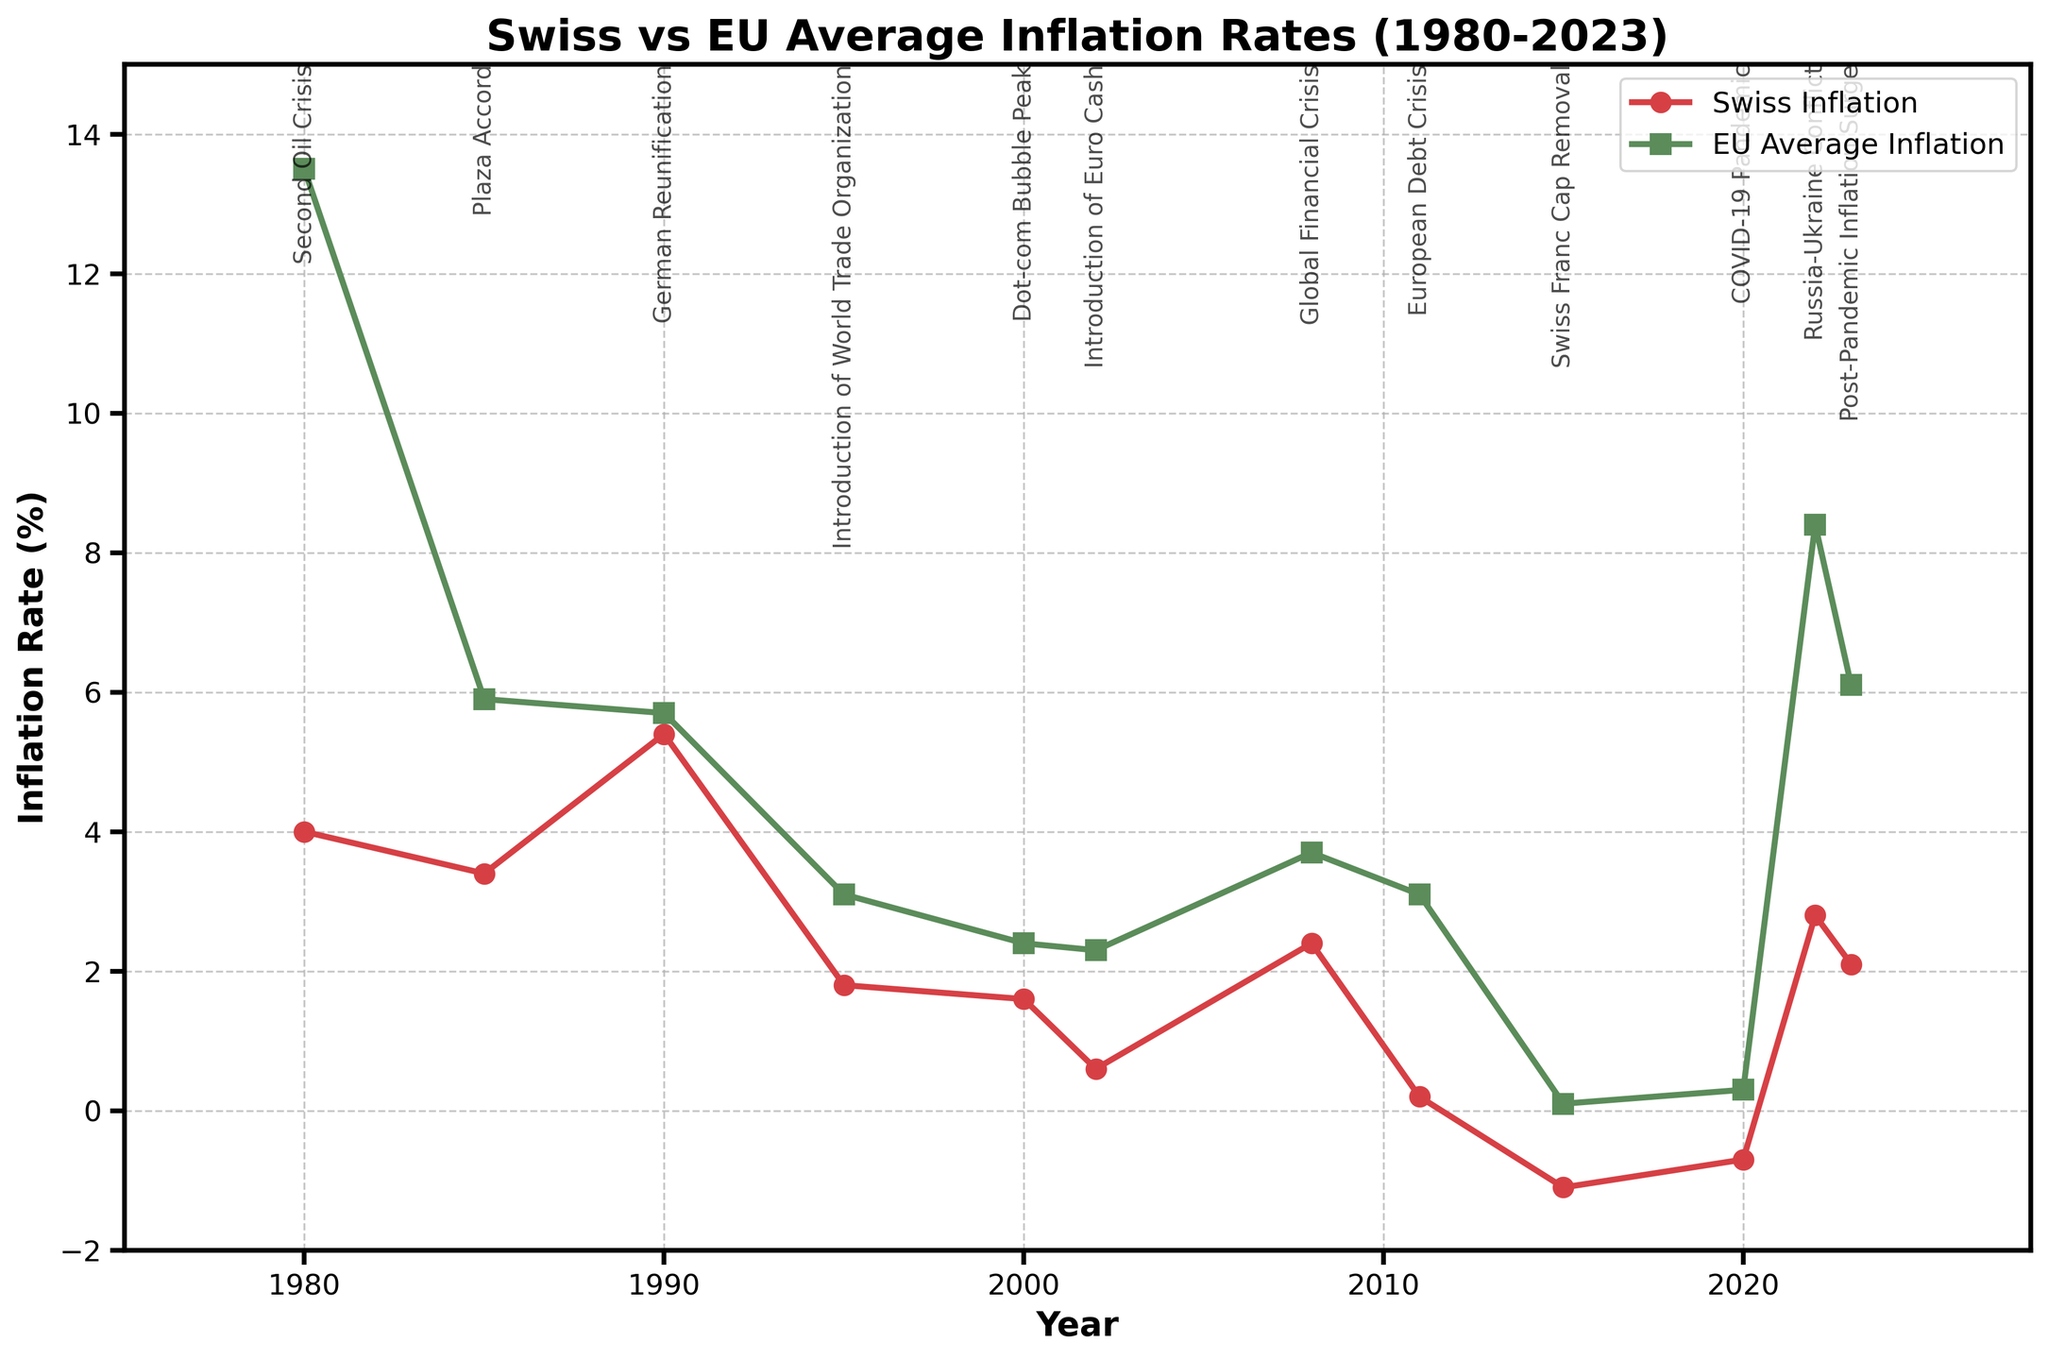What was the highest inflation rate in Switzerland during this period? Looking at the graph, the peak of the Swiss inflation rate occurred in 1990, at a value of 5.4%.
Answer: 5.4% How did the Swiss inflation rate in 2022 compare to the EU average inflation rate in the same year? In 2022, the Swiss inflation rate was 2.8%, while the EU average inflation rate was 8.4%. By comparing these two values, we see that the EU average was significantly higher than Switzerland's.
Answer: The EU average was higher When did Switzerland experience a deflation, and what was the inflation rate then? By identifying where the Swiss inflation rate dips below 0 on the graph, deflation occurred in 2015 and 2020. In 2015, the rate was -1.1%, and in 2020, it was -0.7%.
Answer: 2015 (-1.1%) and 2020 (-0.7%) What economic event is annotated in 2008, and how did it impact inflation in Switzerland compared to the EU? The annotated economic event in 2008 is the "Global Financial Crisis". The Swiss inflation rate in 2008 was 2.4%, whereas the EU average was 3.7%. This indicates that both regions experienced increased inflation, but the EU's was higher.
Answer: Global Financial Crisis Which region had a higher inflation rate during the Dot-com Bubble Peak in 2000? Examining the inflation rates for 2000, Switzerland had an inflation rate of 1.6%, and the EU average was 2.4%. Hence, the EU had a higher inflation rate during that period.
Answer: EU What was the difference in inflation rates between Switzerland and the EU in 1980? In 1980, Switzerland's inflation rate was 4.0%, and the EU average was 13.5%. The difference is calculated as 13.5% - 4.0% = 9.5%.
Answer: 9.5% During which key economic event did Switzerland have an inflation rate close to 0% and what was the exact value? Looking at the annotations and the values, during the "European Debt Crisis" in 2011, the Swiss inflation rate was nearly zero at 0.2%.
Answer: European Debt Crisis (0.2%) How did the inflation rates in Switzerland and the EU compare during the Swiss Franc Cap Removal in 2015? Switzerland had an inflation rate of -1.1% (deflation) in 2015, while the EU had a positive inflation rate of 0.1%. This indicates a significant difference, with Switzerland experiencing deflation, unlike the EU.
Answer: Switzerland had lower inflation (deflation -1.1% vs 0.1% in the EU) What is the trend in Swiss inflation rates from the COVID-19 Pandemic in 2020 to the Post-Pandemic Inflation Surge in 2023? Observing the line for Swiss inflation rate, we see an increase from -0.7% in 2020 to 2.1% in 2023, indicating a rising trend in inflation rates post-pandemic.
Answer: Rising trend 